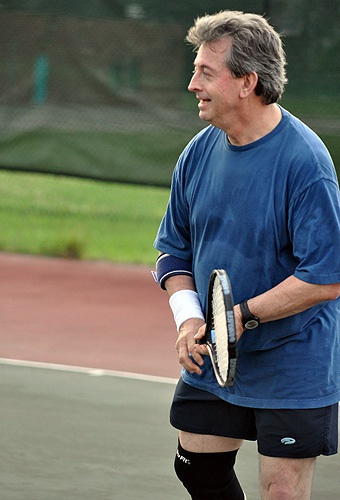Describe the objects in this image and their specific colors. I can see people in black, navy, darkblue, and blue tones and tennis racket in black, beige, gray, and darkgray tones in this image. 